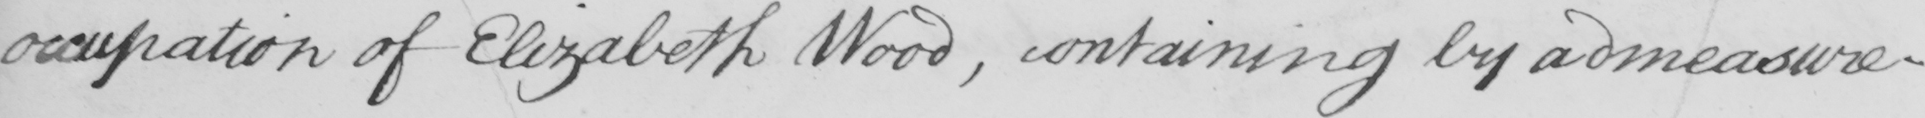What text is written in this handwritten line? occupation of Elizabeth Wood , containing by admeasure- 